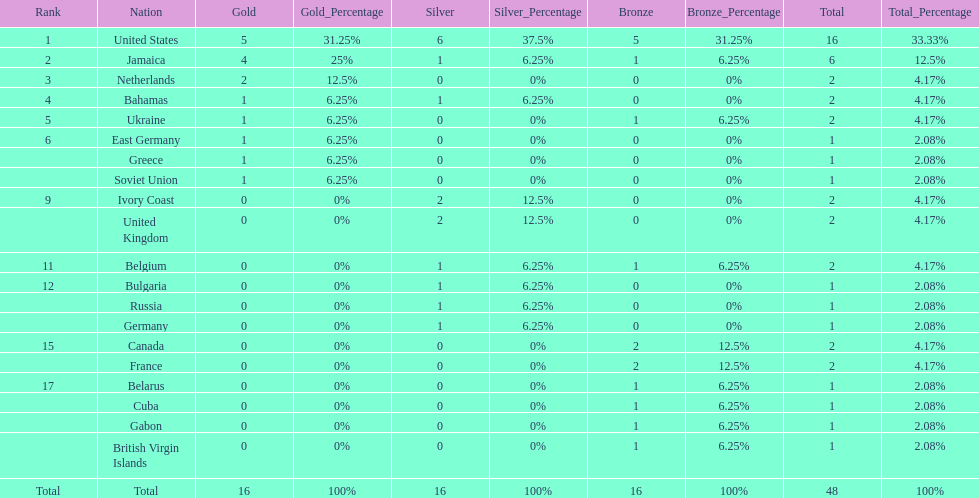Which countries won at least 3 silver medals? United States. 